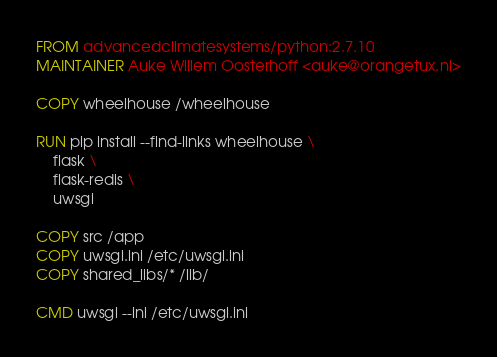<code> <loc_0><loc_0><loc_500><loc_500><_Dockerfile_>FROM advancedclimatesystems/python:2.7.10
MAINTAINER Auke Willem Oosterhoff <auke@orangetux.nl>

COPY wheelhouse /wheelhouse

RUN pip install --find-links wheelhouse \
    flask \
    flask-redis \
    uwsgi

COPY src /app
COPY uwsgi.ini /etc/uwsgi.ini
COPY shared_libs/* /lib/

CMD uwsgi --ini /etc/uwsgi.ini
</code> 